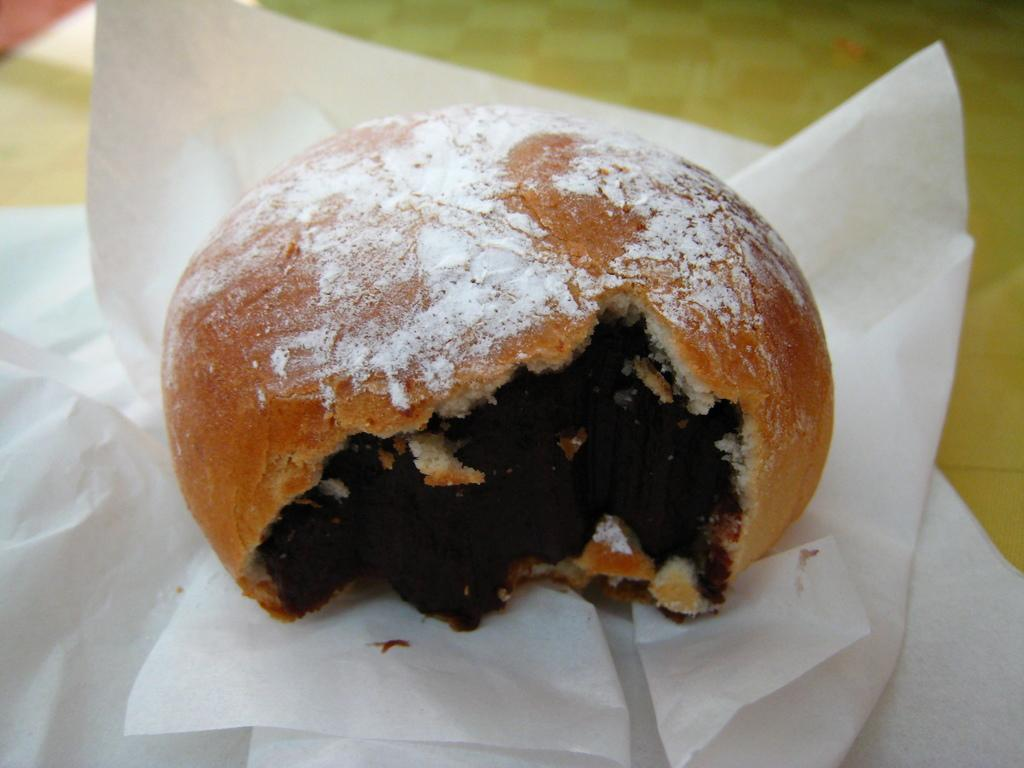What is the main object in the center of the image? There is a table in the center of the image. What can be found on the table? There are food items on the table, as well as a spoon and tissue papers. What type of teaching is being conducted at the table in the image? There is no teaching or educational activity depicted in the image; it simply shows a table with food items, a spoon, and tissue papers. 